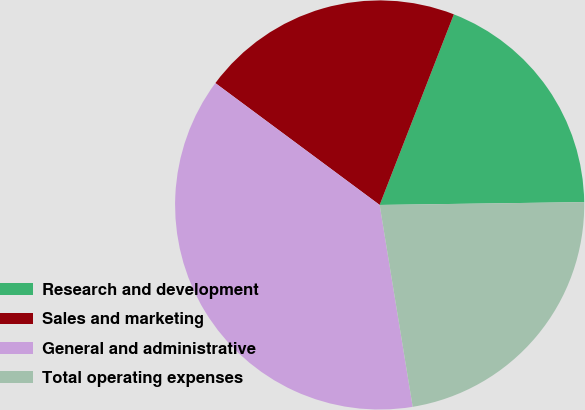Convert chart. <chart><loc_0><loc_0><loc_500><loc_500><pie_chart><fcel>Research and development<fcel>Sales and marketing<fcel>General and administrative<fcel>Total operating expenses<nl><fcel>18.87%<fcel>20.75%<fcel>37.74%<fcel>22.64%<nl></chart> 